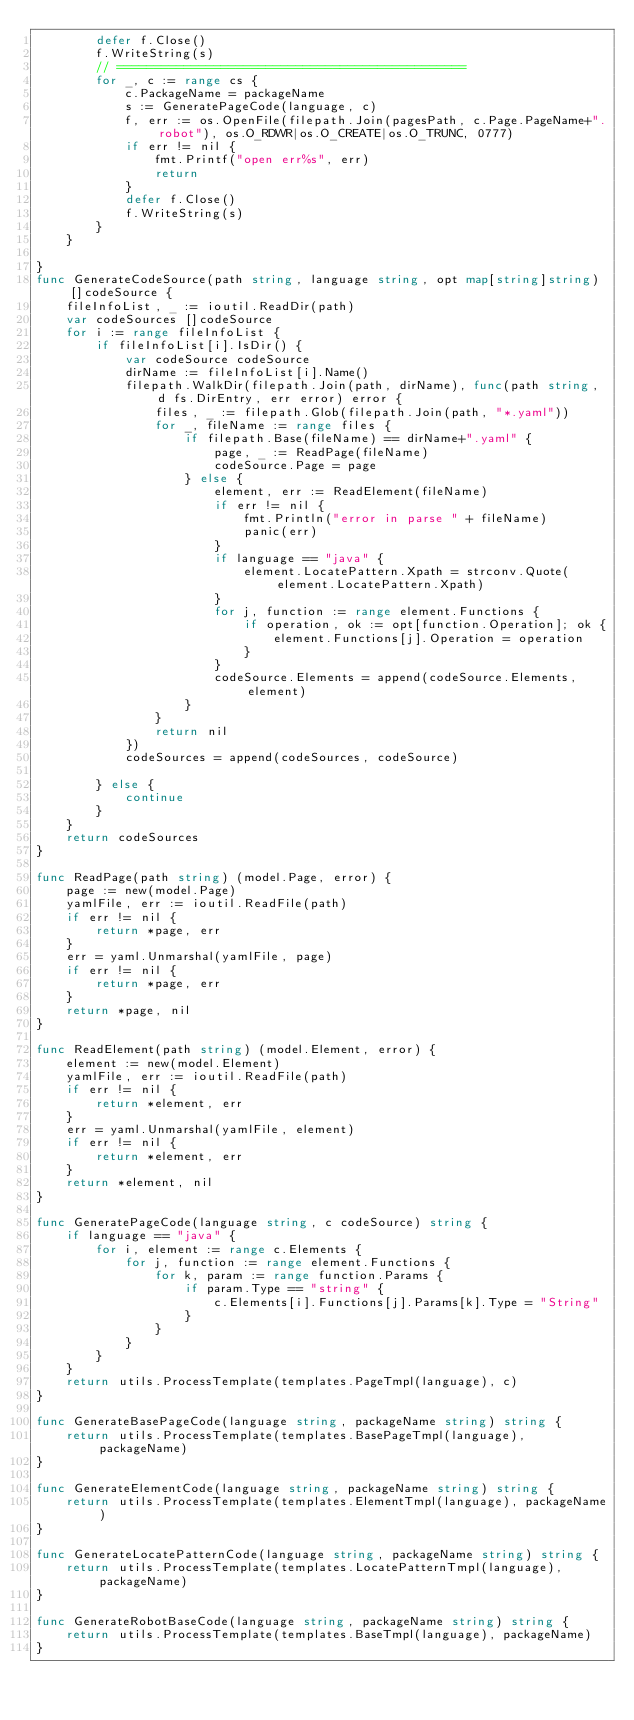<code> <loc_0><loc_0><loc_500><loc_500><_Go_>		defer f.Close()
		f.WriteString(s)
		// ===============================================
		for _, c := range cs {
			c.PackageName = packageName
			s := GeneratePageCode(language, c)
			f, err := os.OpenFile(filepath.Join(pagesPath, c.Page.PageName+".robot"), os.O_RDWR|os.O_CREATE|os.O_TRUNC, 0777)
			if err != nil {
				fmt.Printf("open err%s", err)
				return
			}
			defer f.Close()
			f.WriteString(s)
		}
	}

}
func GenerateCodeSource(path string, language string, opt map[string]string) []codeSource {
	fileInfoList, _ := ioutil.ReadDir(path)
	var codeSources []codeSource
	for i := range fileInfoList {
		if fileInfoList[i].IsDir() {
			var codeSource codeSource
			dirName := fileInfoList[i].Name()
			filepath.WalkDir(filepath.Join(path, dirName), func(path string, d fs.DirEntry, err error) error {
				files, _ := filepath.Glob(filepath.Join(path, "*.yaml"))
				for _, fileName := range files {
					if filepath.Base(fileName) == dirName+".yaml" {
						page, _ := ReadPage(fileName)
						codeSource.Page = page
					} else {
						element, err := ReadElement(fileName)
						if err != nil {
							fmt.Println("error in parse " + fileName)
							panic(err)
						}
						if language == "java" {
							element.LocatePattern.Xpath = strconv.Quote(element.LocatePattern.Xpath)
						}
						for j, function := range element.Functions {
							if operation, ok := opt[function.Operation]; ok {
								element.Functions[j].Operation = operation
							}
						}
						codeSource.Elements = append(codeSource.Elements, element)
					}
				}
				return nil
			})
			codeSources = append(codeSources, codeSource)

		} else {
			continue
		}
	}
	return codeSources
}

func ReadPage(path string) (model.Page, error) {
	page := new(model.Page)
	yamlFile, err := ioutil.ReadFile(path)
	if err != nil {
		return *page, err
	}
	err = yaml.Unmarshal(yamlFile, page)
	if err != nil {
		return *page, err
	}
	return *page, nil
}

func ReadElement(path string) (model.Element, error) {
	element := new(model.Element)
	yamlFile, err := ioutil.ReadFile(path)
	if err != nil {
		return *element, err
	}
	err = yaml.Unmarshal(yamlFile, element)
	if err != nil {
		return *element, err
	}
	return *element, nil
}

func GeneratePageCode(language string, c codeSource) string {
	if language == "java" {
		for i, element := range c.Elements {
			for j, function := range element.Functions {
				for k, param := range function.Params {
					if param.Type == "string" {
						c.Elements[i].Functions[j].Params[k].Type = "String"
					}
				}
			}
		}
	}
	return utils.ProcessTemplate(templates.PageTmpl(language), c)
}

func GenerateBasePageCode(language string, packageName string) string {
	return utils.ProcessTemplate(templates.BasePageTmpl(language), packageName)
}

func GenerateElementCode(language string, packageName string) string {
	return utils.ProcessTemplate(templates.ElementTmpl(language), packageName)
}

func GenerateLocatePatternCode(language string, packageName string) string {
	return utils.ProcessTemplate(templates.LocatePatternTmpl(language), packageName)
}

func GenerateRobotBaseCode(language string, packageName string) string {
	return utils.ProcessTemplate(templates.BaseTmpl(language), packageName)
}
</code> 